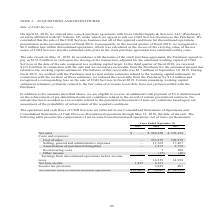According to Cubic's financial document, How was the loss within discontinued operations in 2018 calculated? the excess of the carrying value of the net assets of CGD Services less the estimated sales price in the stock purchase agreement less estimated selling costs. The document states: "discontinued operations, which was calculated as the excess of the carrying value of the net assets of CGD Services less the estimated sales price in ..." Also, What is the eligibility to receive an additional cash payment of $3.0 million based on? the achievement of pre-determined earn-out conditions related to the award of certain government contracts. The document states: "additional cash payment of $3.0 million based on the achievement of pre-determined earn-out conditions related to the award of certain government cont..." Also, What are the components under Costs and Expenses? The document contains multiple relevant values: Cost of sales, Selling, general and administrative expenses, Amortization of purchased intangibles, Restructuring costs, Other income. From the document: "Cost of sales — 235,279 342,819 Selling, general and administrative expenses — 11,365 17,487 ortization of purchased intangibles — 1,373 2,752 Restruc..." Also, How many components are there under Costs and Expenses? Counting the relevant items in the document: Cost of sales, Selling, general and administrative expenses, Amortization of purchased intangibles, Restructuring costs, Other income, I find 5 instances. The key data points involved are: Amortization of purchased intangibles, Cost of sales, Other income. Also, can you calculate: What is the change in net sales in 2018 from 2017? Based on the calculation: 262,228-378,152, the result is -115924 (in thousands). This is based on the information: "Net sales $ — $ 262,228 $ 378,152 Costs and expenses: Net sales $ — $ 262,228 $ 378,152 Costs and expenses:..." The key data points involved are: 262,228, 378,152. Also, can you calculate: What is the percentage change in net sales in 2018 from 2017? To answer this question, I need to perform calculations using the financial data. The calculation is: (262,228-378,152)/378,152, which equals -30.66 (percentage). This is based on the information: "Net sales $ — $ 262,228 $ 378,152 Costs and expenses: Net sales $ — $ 262,228 $ 378,152 Costs and expenses:..." The key data points involved are: 262,228, 378,152. 